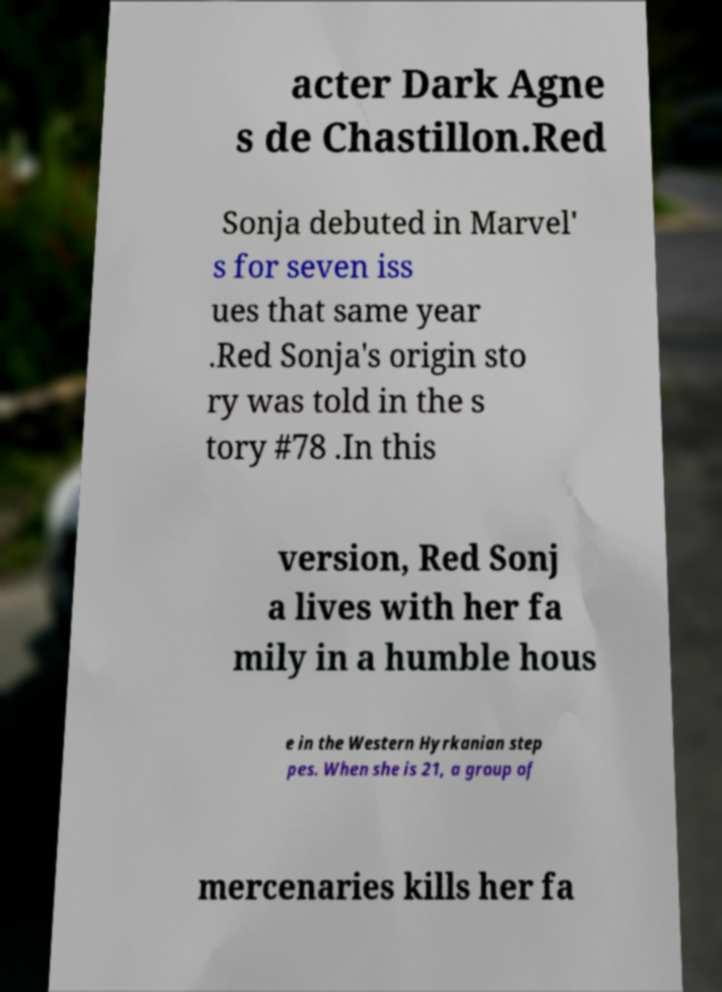Can you read and provide the text displayed in the image?This photo seems to have some interesting text. Can you extract and type it out for me? acter Dark Agne s de Chastillon.Red Sonja debuted in Marvel' s for seven iss ues that same year .Red Sonja's origin sto ry was told in the s tory #78 .In this version, Red Sonj a lives with her fa mily in a humble hous e in the Western Hyrkanian step pes. When she is 21, a group of mercenaries kills her fa 